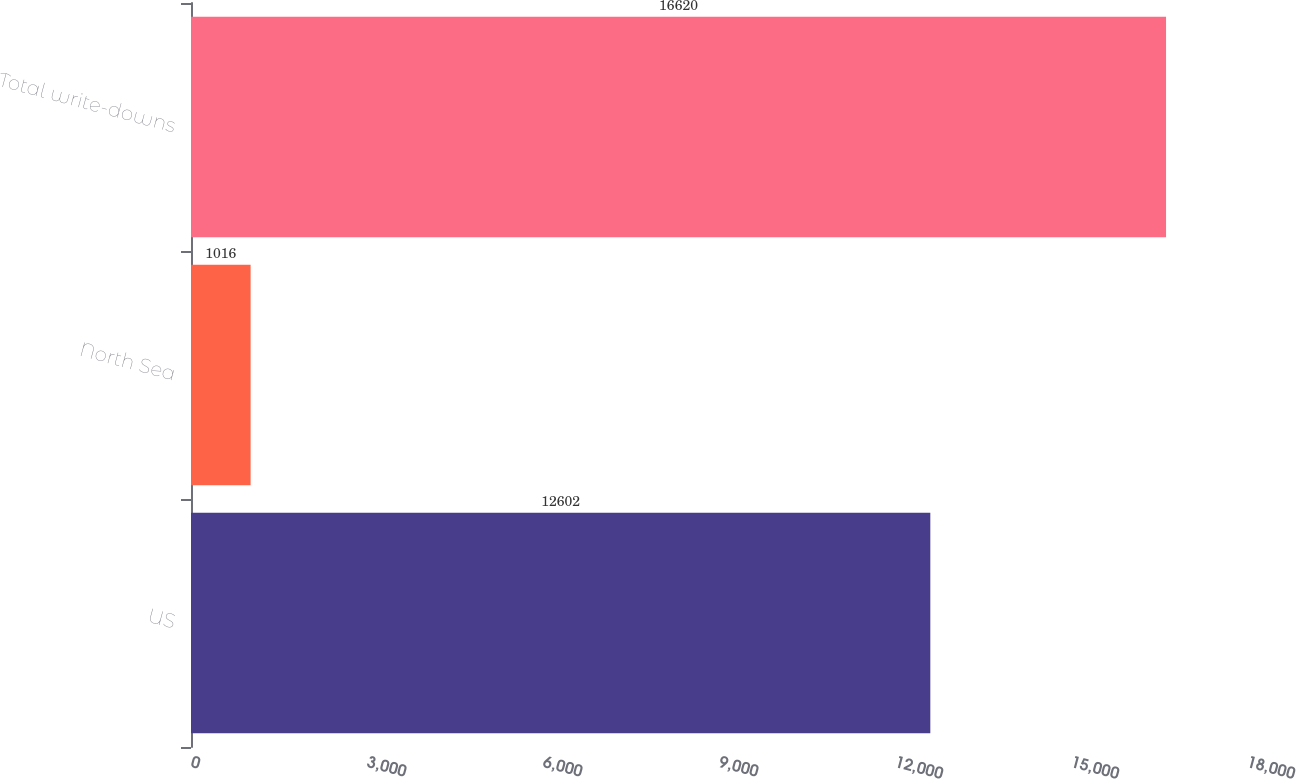Convert chart to OTSL. <chart><loc_0><loc_0><loc_500><loc_500><bar_chart><fcel>US<fcel>North Sea<fcel>Total write-downs<nl><fcel>12602<fcel>1016<fcel>16620<nl></chart> 